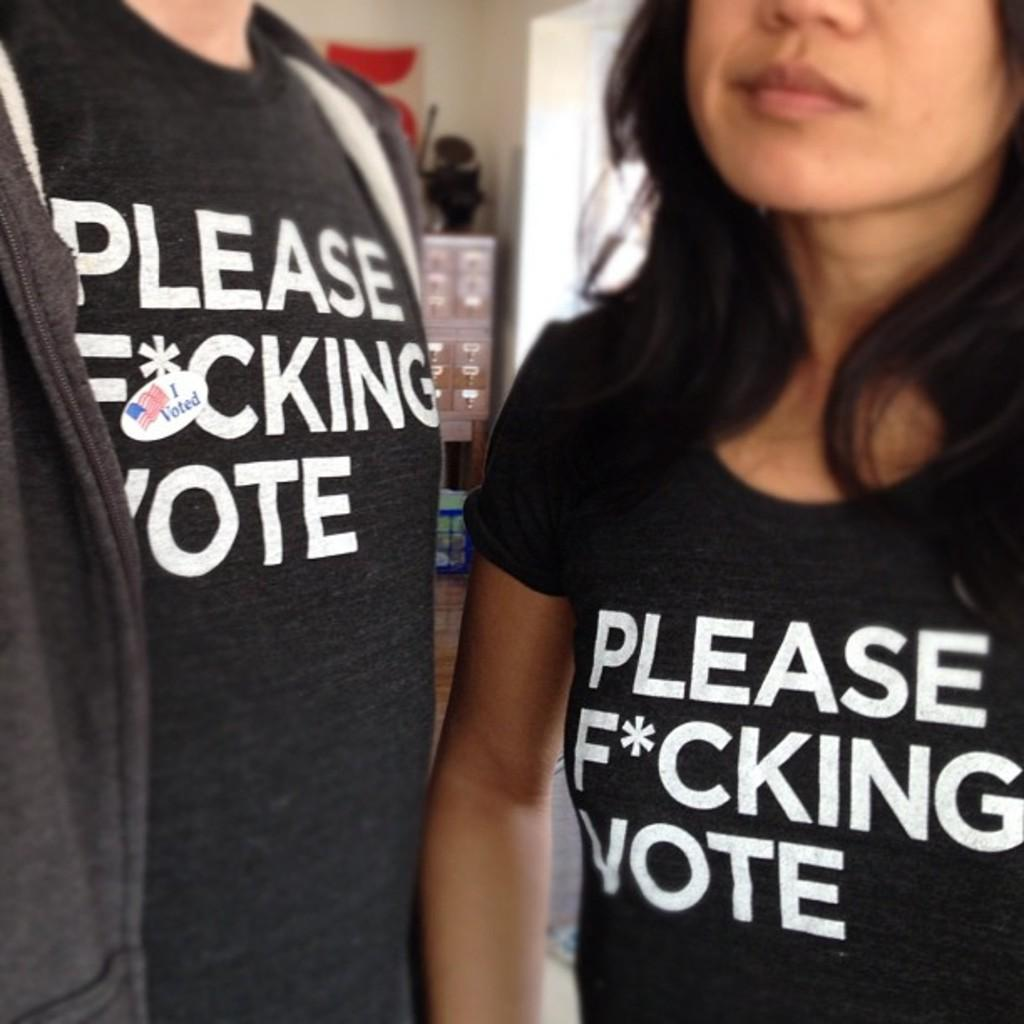<image>
Write a terse but informative summary of the picture. The person on the left has a sticker that indicates he voted. 